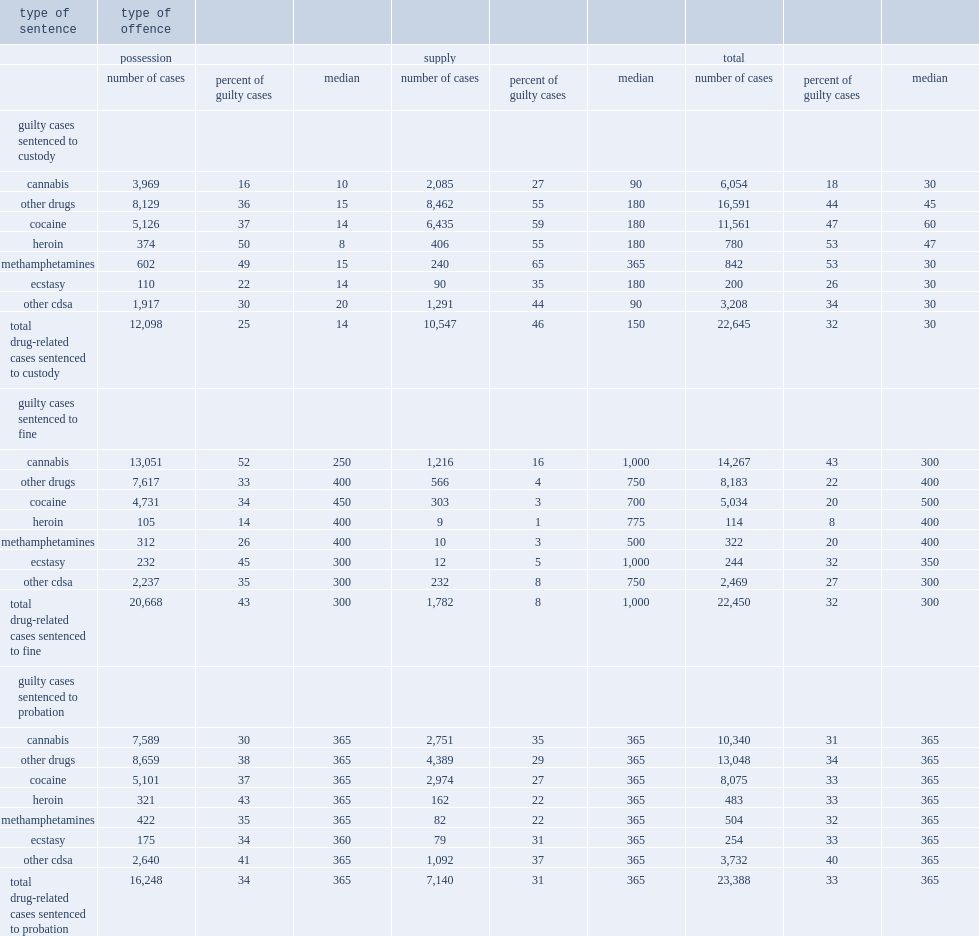A sentence of custody was imposed in what percentage of all completed drug-related cases in adult criminal court with a finding of guilt from 2008/2009 to 2011/2012? 32.0. What is the percentage of drug-related cases involving supply offences with a decision of guilt included custody as part of the sentence from 2008/2009 to 2011/2012? 46.0. What is the percentage of drug-repated cases involving possession offences with a decision of guilt included custody as part of the sentence from 2008/2009 to 2011/2012? 25.0. What is the percentage of guilty cases involving cannabis possession involved custody from 2008/2009 to 2011/2012? 16.0. What is the percentage of guilty cases involving cannabis supply involved custody from 2008/2009 to 2011/2012? 27.0. What is the percentage of guilty cases involving other drugs supply involved custody from 2008/2009 to 2011/2012? 55.0. What is the percentage of guilty cases involving other drugs possession involved custody from 2008/2009 to 2011/2012? 36.0. 